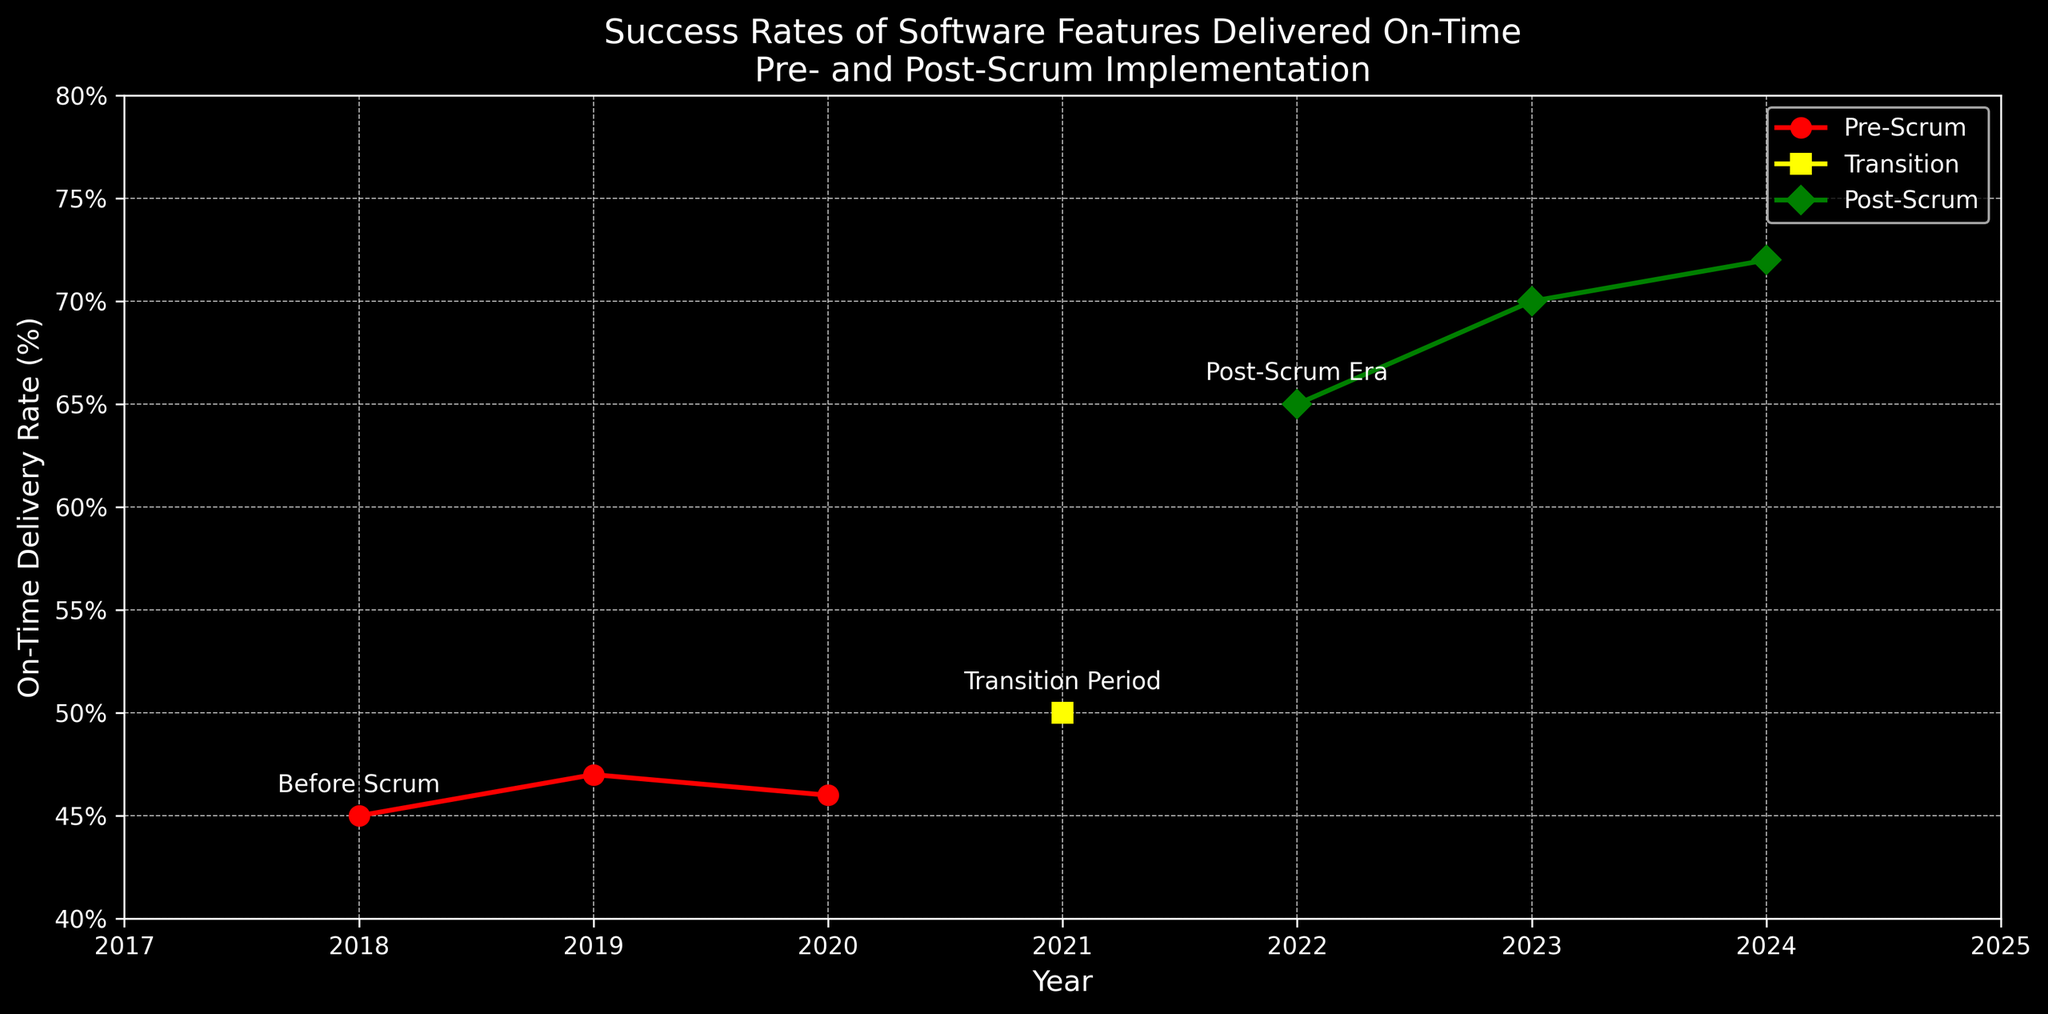What is the on-time delivery rate for 2021? The figure shows the on-time delivery rates for each year. For 2021, the data point aligns with the transition period marked with a 50% delivery rate.
Answer: 50% How did the on-time delivery rate change from 2020 to 2022? To determine the change, subtract the 2020 rate from the 2022 rate. The figure shows 46% in 2020 and 65% in 2022. So, the change is 65% - 46% = 19%.
Answer: 19% Which period saw a transition in the on-time delivery methodology, according to the annotations? The figure annotates a "Transition Period" in 2021, indicating a shift in methodology during that year.
Answer: 2021 In which year did the on-time delivery rate first exceed 60%? Looking at the y-axis and data points, the delivery rate first exceeds 60% in 2022, labeled in the "Post-Scrum Era".
Answer: 2022 What was the average on-time delivery rate during the Post-Scrum period? Post-Scrum period includes 2022, 2023, and 2024. The rates are 65%, 70%, and 72%. Average rate = (65 + 70 + 72) / 3 = 67.67%.
Answer: 67.67% Compare the on-time delivery rates of 2018 and 2024. What is the difference? From the figure, the delivery rate in 2018 is 45%, and in 2024 it is 72%. The difference can be calculated as 72% - 45% = 27%.
Answer: 27% How did the delivery rate trend from the Pre-Scrum to Post-Scrum eras? The Pre-Scrum era (2018-2020) had rates of 45%, 47%, and 46%. The Post-Scrum era (2022-2024) had rates of 65%, 70%, and 72%. Rates increased significantly after the Scrum implementation.
Answer: Significant increase Which color represents the Post-Scrum period in the figure? The figure uses different colors for each period. The Post-Scrum period is shown in green.
Answer: Green What is the total improvement in on-time delivery rate from the start of the Pre-Scrum era to the end of the Post-Scrum era? The start of the Pre-Scrum era is 2018 with 45%, and the end of the Post-Scrum era is 2024 with 72%. The total improvement is 72% - 45% = 27%.
Answer: 27% How did the on-time delivery rate change between the Pre-Scrum and the Transition period? The last rate in the Pre-Scrum era (2020) was 46%, and during the Transition period (2021) it was 50%. The change is 50% - 46% = 4%.
Answer: 4% 